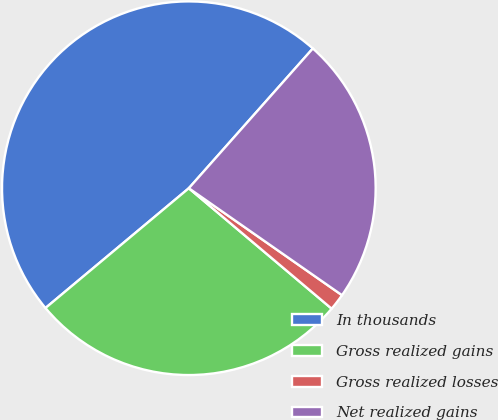<chart> <loc_0><loc_0><loc_500><loc_500><pie_chart><fcel>In thousands<fcel>Gross realized gains<fcel>Gross realized losses<fcel>Net realized gains<nl><fcel>47.63%<fcel>27.77%<fcel>1.45%<fcel>23.15%<nl></chart> 